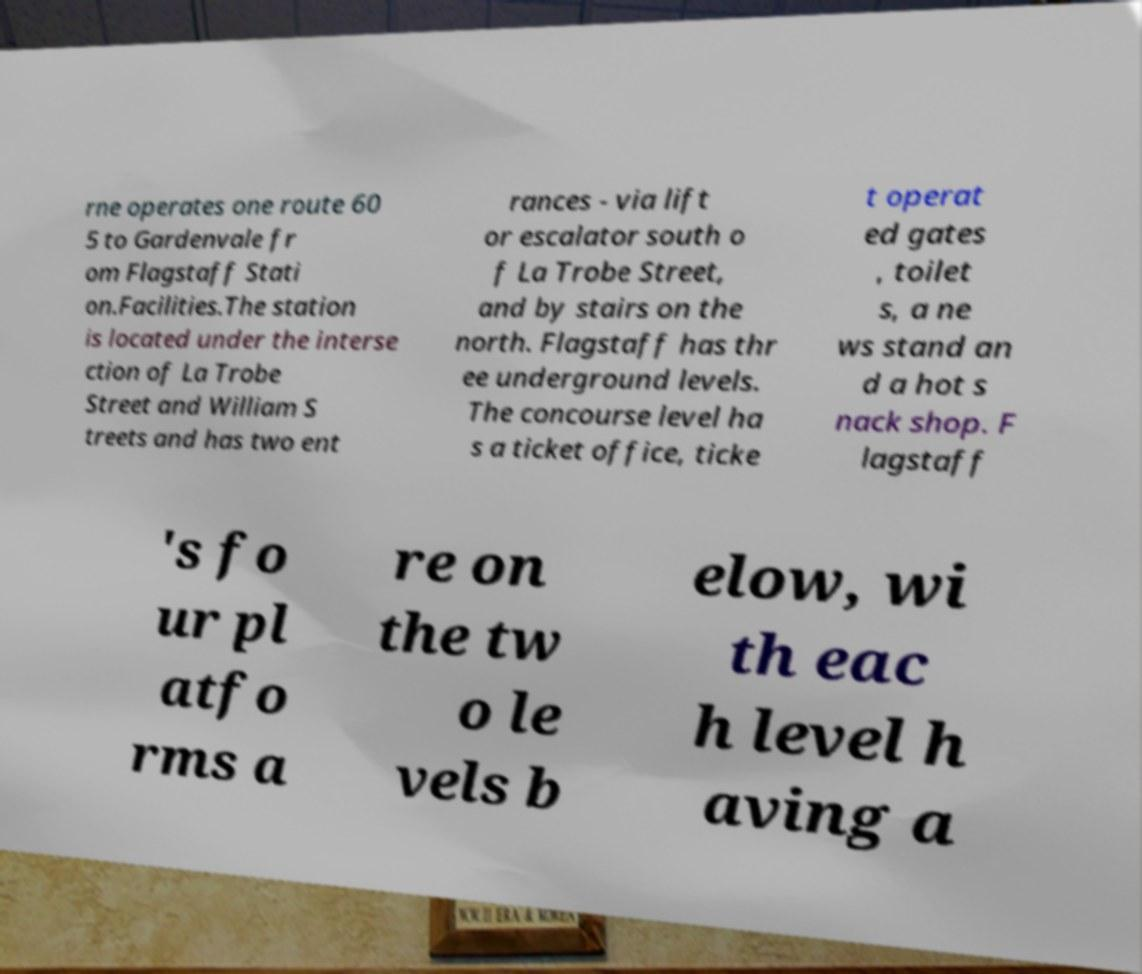Can you read and provide the text displayed in the image?This photo seems to have some interesting text. Can you extract and type it out for me? rne operates one route 60 5 to Gardenvale fr om Flagstaff Stati on.Facilities.The station is located under the interse ction of La Trobe Street and William S treets and has two ent rances - via lift or escalator south o f La Trobe Street, and by stairs on the north. Flagstaff has thr ee underground levels. The concourse level ha s a ticket office, ticke t operat ed gates , toilet s, a ne ws stand an d a hot s nack shop. F lagstaff 's fo ur pl atfo rms a re on the tw o le vels b elow, wi th eac h level h aving a 